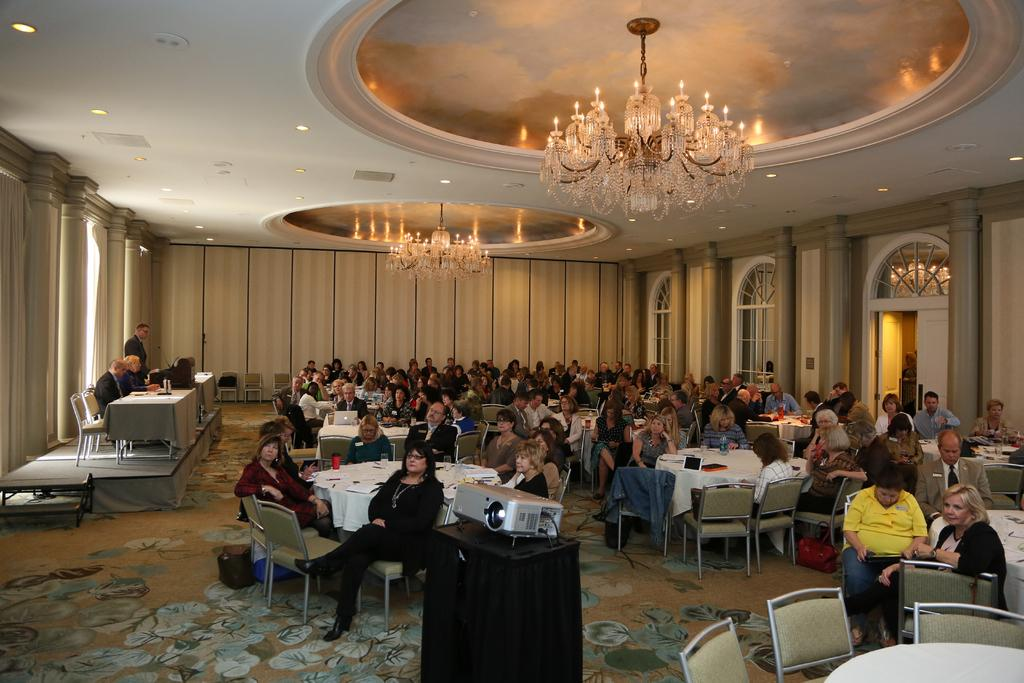What is the main subject of the image? The main subject of the image is a group of people. What are the people in the image doing? The people are sitting on chairs in the image. What can be seen on a table in the image? There is a device on a table in the image. What type of lighting fixture is present in the image? There is a chandelier in the image. What type of parent is depicted in the image? There is no parent present in the image; it features a group of people sitting on chairs. What type of liquid is being washed off the device in the image? There is no washing or liquid present in the image; it only shows a device on a table. 